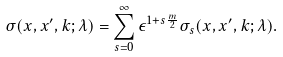<formula> <loc_0><loc_0><loc_500><loc_500>\sigma ( x , x ^ { \prime } , k ; \lambda ) = \sum _ { s = 0 } ^ { \infty } \epsilon ^ { 1 + s \frac { m } { 2 } } \sigma _ { s } ( x , x ^ { \prime } , k ; \lambda ) .</formula> 